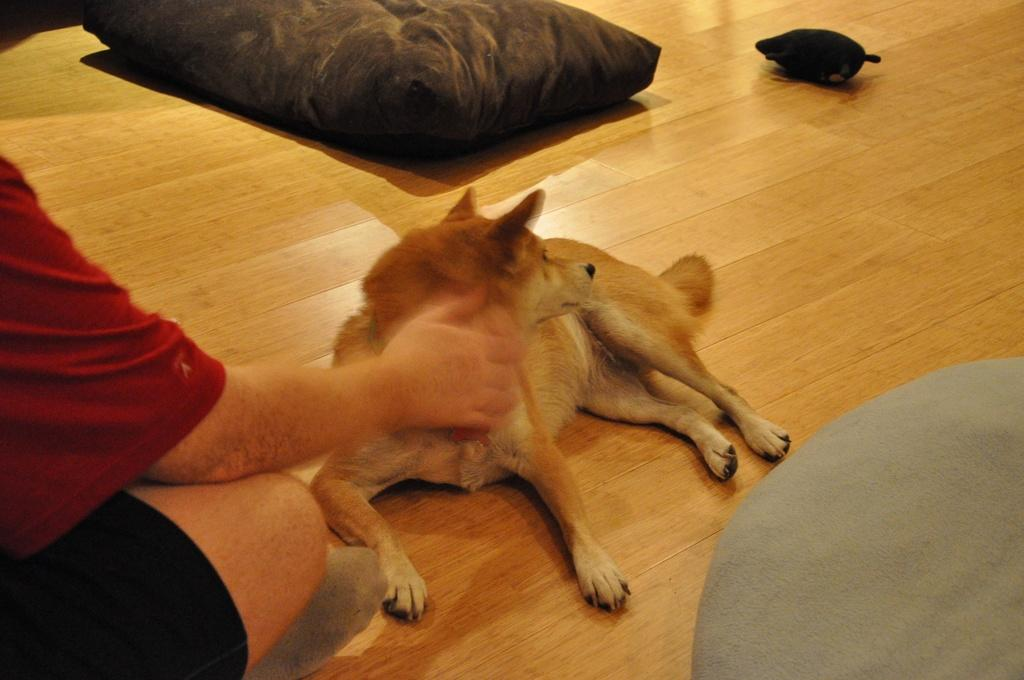What type of animal is in the image? There is a dog in the image. What is the dog resting on? There is a pillow in the image. What can be seen on the wooden platform? There are objects on a wooden platform. Who is present on the left side of the image? There is a person on the left side of the image. What type of powder is being used by the person in the image? There is no powder visible in the image, and the person's actions are not described. 